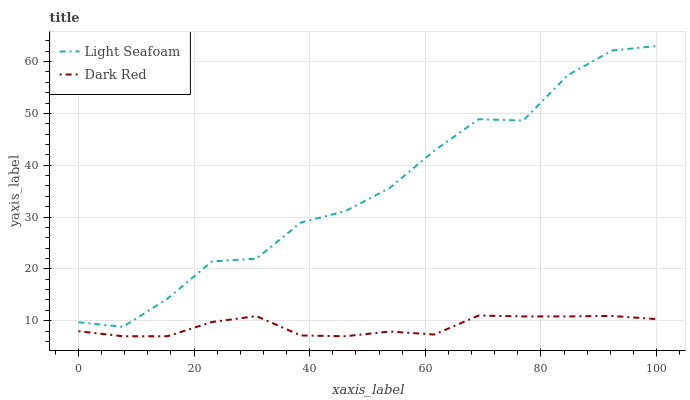Does Dark Red have the minimum area under the curve?
Answer yes or no. Yes. Does Light Seafoam have the maximum area under the curve?
Answer yes or no. Yes. Does Light Seafoam have the minimum area under the curve?
Answer yes or no. No. Is Dark Red the smoothest?
Answer yes or no. Yes. Is Light Seafoam the roughest?
Answer yes or no. Yes. Is Light Seafoam the smoothest?
Answer yes or no. No. Does Dark Red have the lowest value?
Answer yes or no. Yes. Does Light Seafoam have the lowest value?
Answer yes or no. No. Does Light Seafoam have the highest value?
Answer yes or no. Yes. Is Dark Red less than Light Seafoam?
Answer yes or no. Yes. Is Light Seafoam greater than Dark Red?
Answer yes or no. Yes. Does Dark Red intersect Light Seafoam?
Answer yes or no. No. 